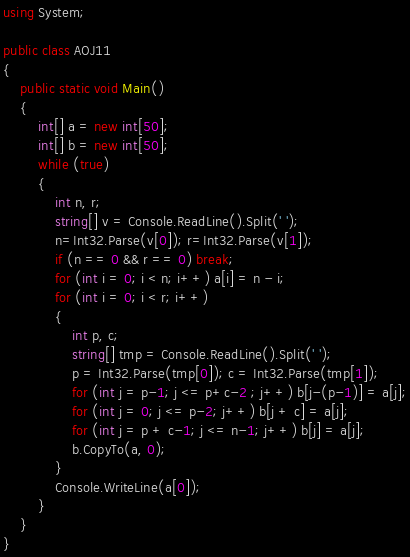<code> <loc_0><loc_0><loc_500><loc_500><_C#_>using System;

public class AOJ11
{
    public static void Main()
    {
        int[] a = new int[50];
        int[] b = new int[50];
        while (true)
        {
            int n, r;
            string[] v = Console.ReadLine().Split(' ');
            n=Int32.Parse(v[0]); r=Int32.Parse(v[1]);
            if (n == 0 && r == 0) break;
            for (int i = 0; i < n; i++) a[i] = n - i;
            for (int i = 0; i < r; i++)
            {
                int p, c;
                string[] tmp = Console.ReadLine().Split(' ');
                p = Int32.Parse(tmp[0]); c = Int32.Parse(tmp[1]);
                for (int j = p-1; j <= p+c-2 ; j++) b[j-(p-1)] = a[j];
                for (int j = 0; j <= p-2; j++) b[j + c] = a[j];
                for (int j = p + c-1; j <= n-1; j++) b[j] = a[j];
                b.CopyTo(a, 0);
            }
            Console.WriteLine(a[0]);
        }
    }
}</code> 